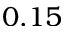<formula> <loc_0><loc_0><loc_500><loc_500>0 . 1 5</formula> 